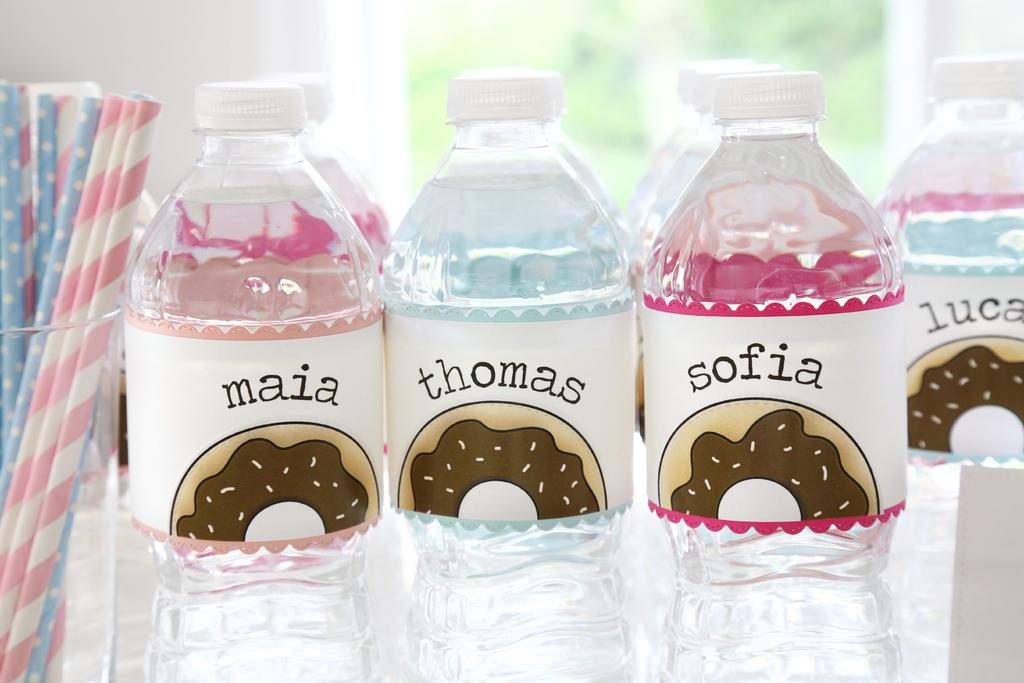<image>
Relay a brief, clear account of the picture shown. A display of plastic bottles with labels that have children's names and a picture of a donut while there is a glass of paper straws next to them 